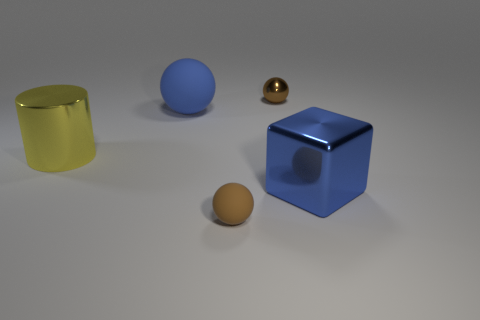What shape is the object that is both left of the big blue cube and in front of the big cylinder?
Keep it short and to the point. Sphere. There is a brown ball in front of the small metal sphere that is behind the tiny brown thing that is in front of the large shiny cube; what is its material?
Provide a succinct answer. Rubber. Are there more big blue cubes to the left of the big blue shiny cube than brown balls that are in front of the big sphere?
Keep it short and to the point. No. How many spheres have the same material as the large blue cube?
Offer a terse response. 1. There is a brown object that is behind the tiny brown rubber sphere; is it the same shape as the matte object that is in front of the shiny block?
Provide a succinct answer. Yes. The metal object that is to the right of the brown metallic sphere is what color?
Make the answer very short. Blue. Is there a big rubber thing of the same shape as the large blue metal object?
Your response must be concise. No. What is the material of the big yellow cylinder?
Provide a short and direct response. Metal. How big is the ball that is to the right of the blue sphere and behind the metal cylinder?
Your answer should be compact. Small. What material is the thing that is the same color as the metal cube?
Your answer should be compact. Rubber. 